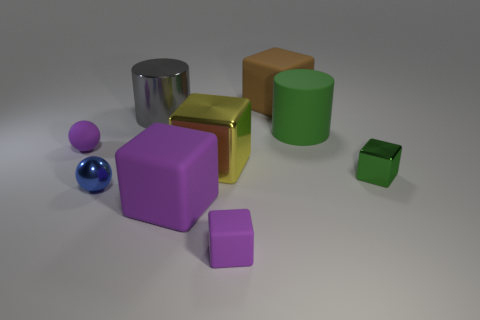Is there any other thing that has the same material as the brown object?
Keep it short and to the point. Yes. How many cylinders are green things or big green rubber things?
Provide a short and direct response. 1. Do the cylinder that is behind the large rubber cylinder and the cube to the right of the large brown thing have the same size?
Offer a very short reply. No. There is a large cylinder on the right side of the purple matte object that is to the right of the yellow object; what is it made of?
Provide a succinct answer. Rubber. Is the number of large brown rubber things that are in front of the purple rubber sphere less than the number of blue metal balls?
Ensure brevity in your answer.  Yes. The green object that is the same material as the large yellow thing is what shape?
Ensure brevity in your answer.  Cube. What number of other objects are there of the same shape as the large green matte thing?
Offer a terse response. 1. What number of cyan objects are metallic blocks or small spheres?
Keep it short and to the point. 0. Is the brown object the same shape as the large green object?
Provide a short and direct response. No. Is there a thing that is left of the big matte block behind the big purple matte cube?
Your response must be concise. Yes. 